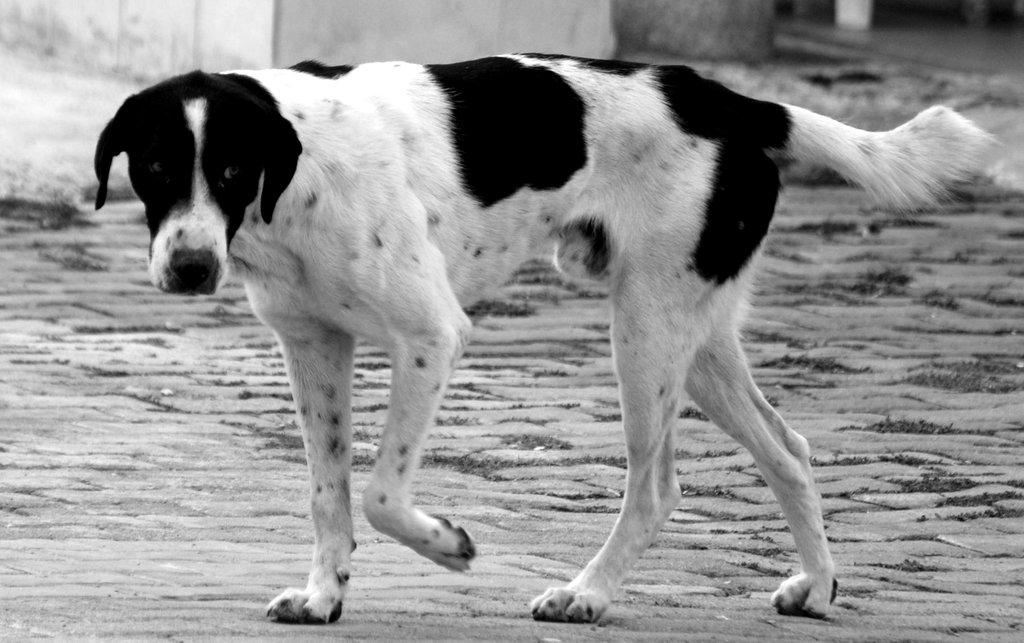What type of animal is in the image? There is a dog in the image. Where is the dog located? The dog is on the ground. What can be seen in the distance in the image? There is a wall in the background of the image. What else is visible in the background of the image? There are objects visible in the background of the image. What type of knife is the cow using to cut the hope in the image? There is no knife, cow, or hope present in the image. 